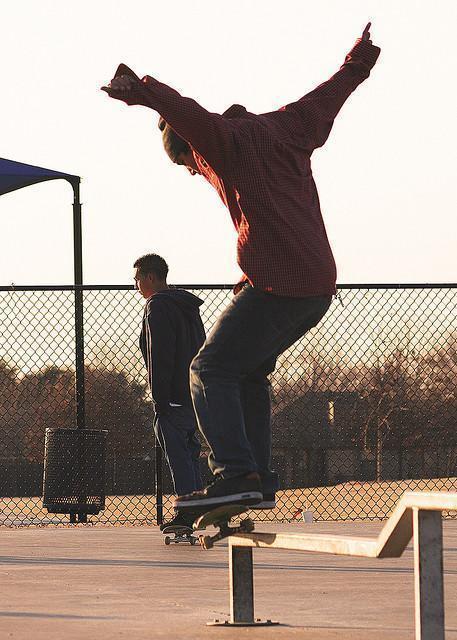What is the skater doing on the rail?
Pick the correct solution from the four options below to address the question.
Options: Grinding, flipping, manualing, whipping. Grinding. 